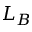Convert formula to latex. <formula><loc_0><loc_0><loc_500><loc_500>L _ { B }</formula> 